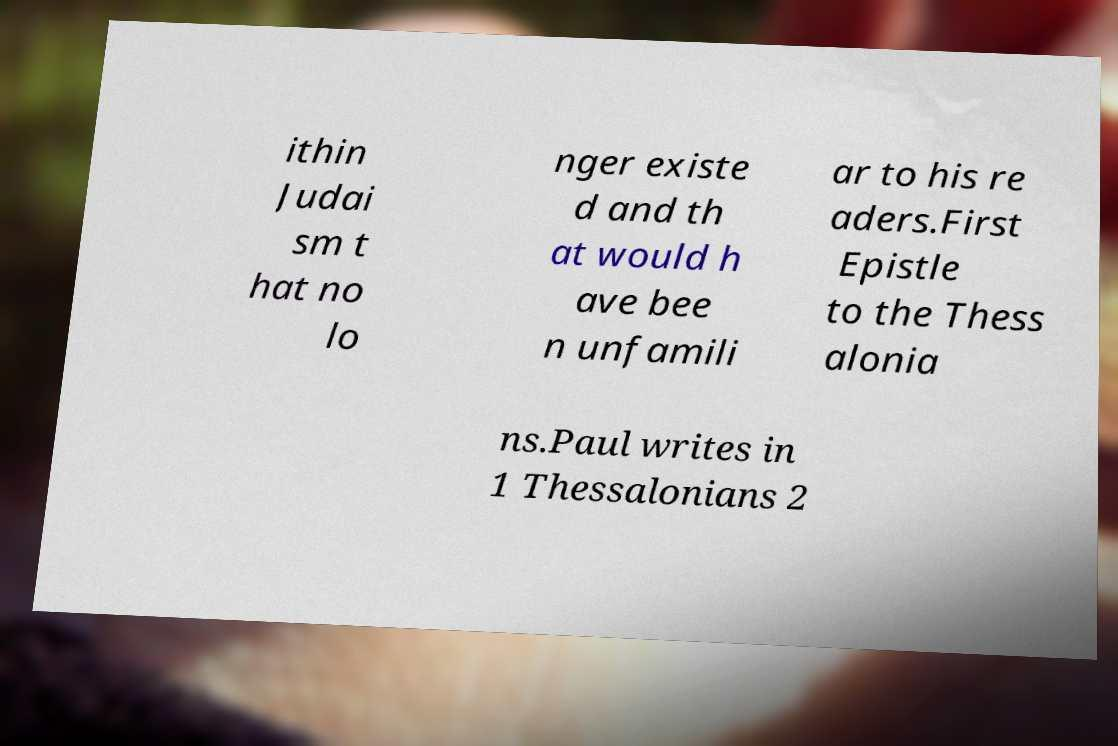Can you read and provide the text displayed in the image?This photo seems to have some interesting text. Can you extract and type it out for me? ithin Judai sm t hat no lo nger existe d and th at would h ave bee n unfamili ar to his re aders.First Epistle to the Thess alonia ns.Paul writes in 1 Thessalonians 2 